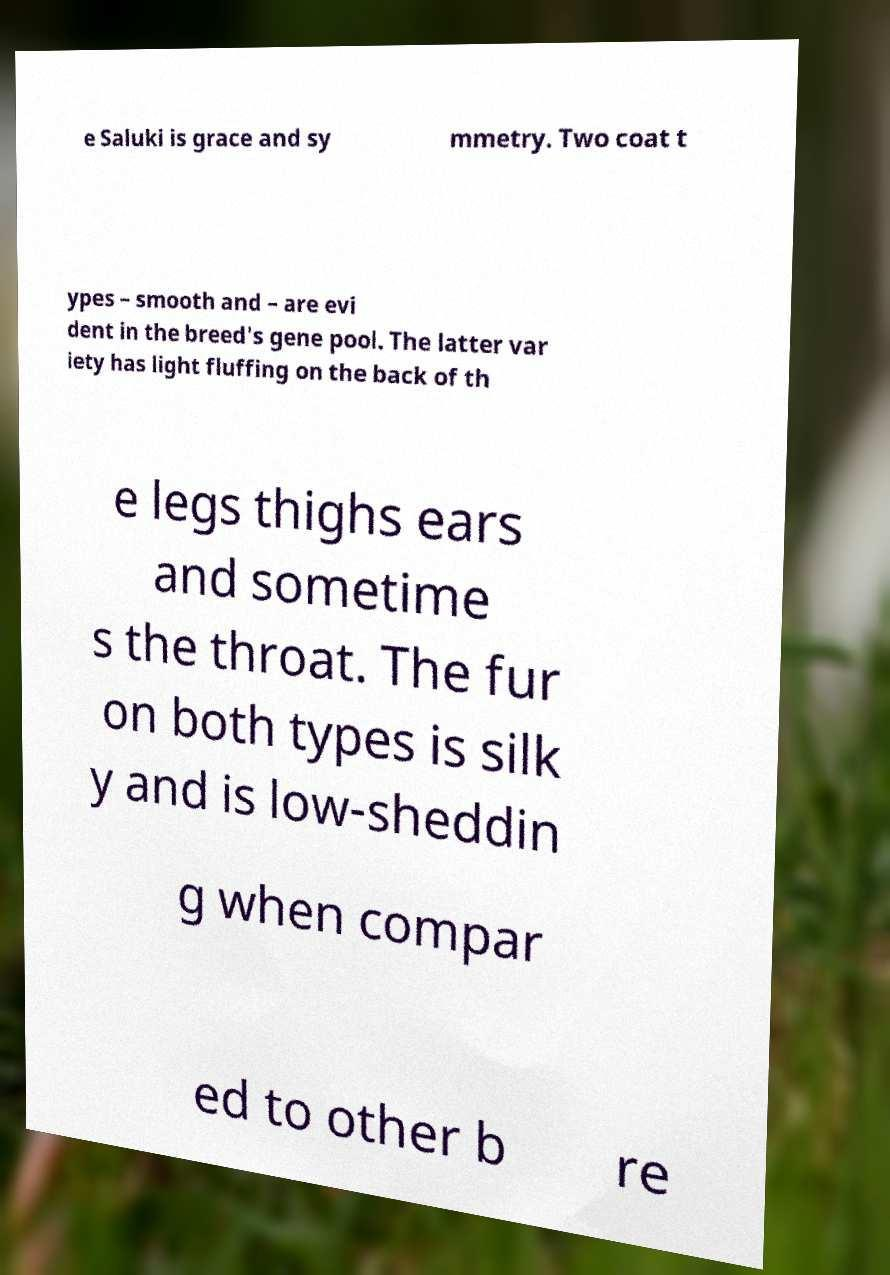Please identify and transcribe the text found in this image. e Saluki is grace and sy mmetry. Two coat t ypes – smooth and – are evi dent in the breed's gene pool. The latter var iety has light fluffing on the back of th e legs thighs ears and sometime s the throat. The fur on both types is silk y and is low-sheddin g when compar ed to other b re 